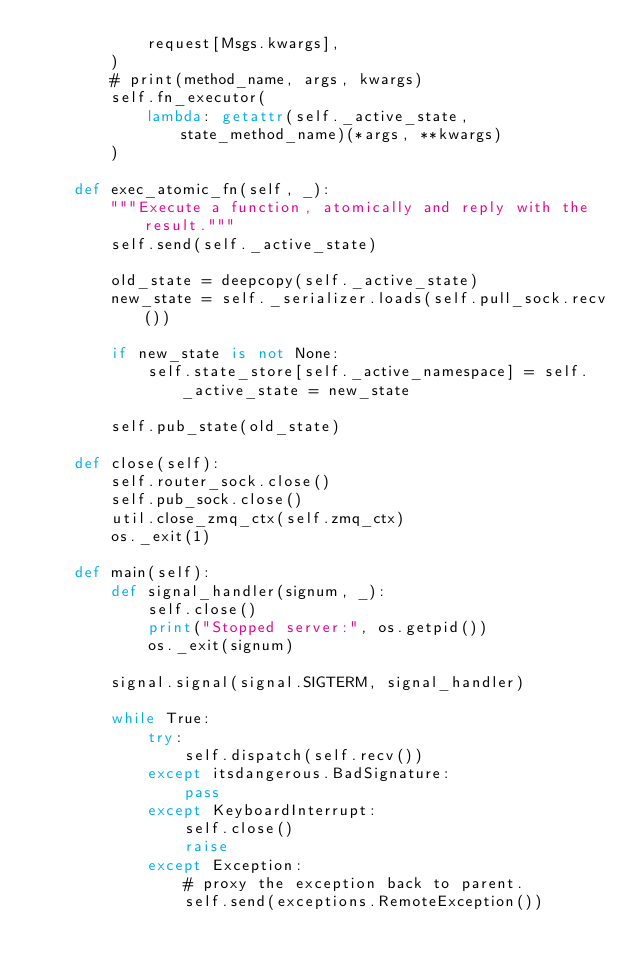Convert code to text. <code><loc_0><loc_0><loc_500><loc_500><_Python_>            request[Msgs.kwargs],
        )
        # print(method_name, args, kwargs)
        self.fn_executor(
            lambda: getattr(self._active_state, state_method_name)(*args, **kwargs)
        )

    def exec_atomic_fn(self, _):
        """Execute a function, atomically and reply with the result."""
        self.send(self._active_state)

        old_state = deepcopy(self._active_state)
        new_state = self._serializer.loads(self.pull_sock.recv())

        if new_state is not None:
            self.state_store[self._active_namespace] = self._active_state = new_state

        self.pub_state(old_state)

    def close(self):
        self.router_sock.close()
        self.pub_sock.close()
        util.close_zmq_ctx(self.zmq_ctx)
        os._exit(1)

    def main(self):
        def signal_handler(signum, _):
            self.close()
            print("Stopped server:", os.getpid())
            os._exit(signum)

        signal.signal(signal.SIGTERM, signal_handler)

        while True:
            try:
                self.dispatch(self.recv())
            except itsdangerous.BadSignature:
                pass
            except KeyboardInterrupt:
                self.close()
                raise
            except Exception:
                # proxy the exception back to parent.
                self.send(exceptions.RemoteException())
</code> 